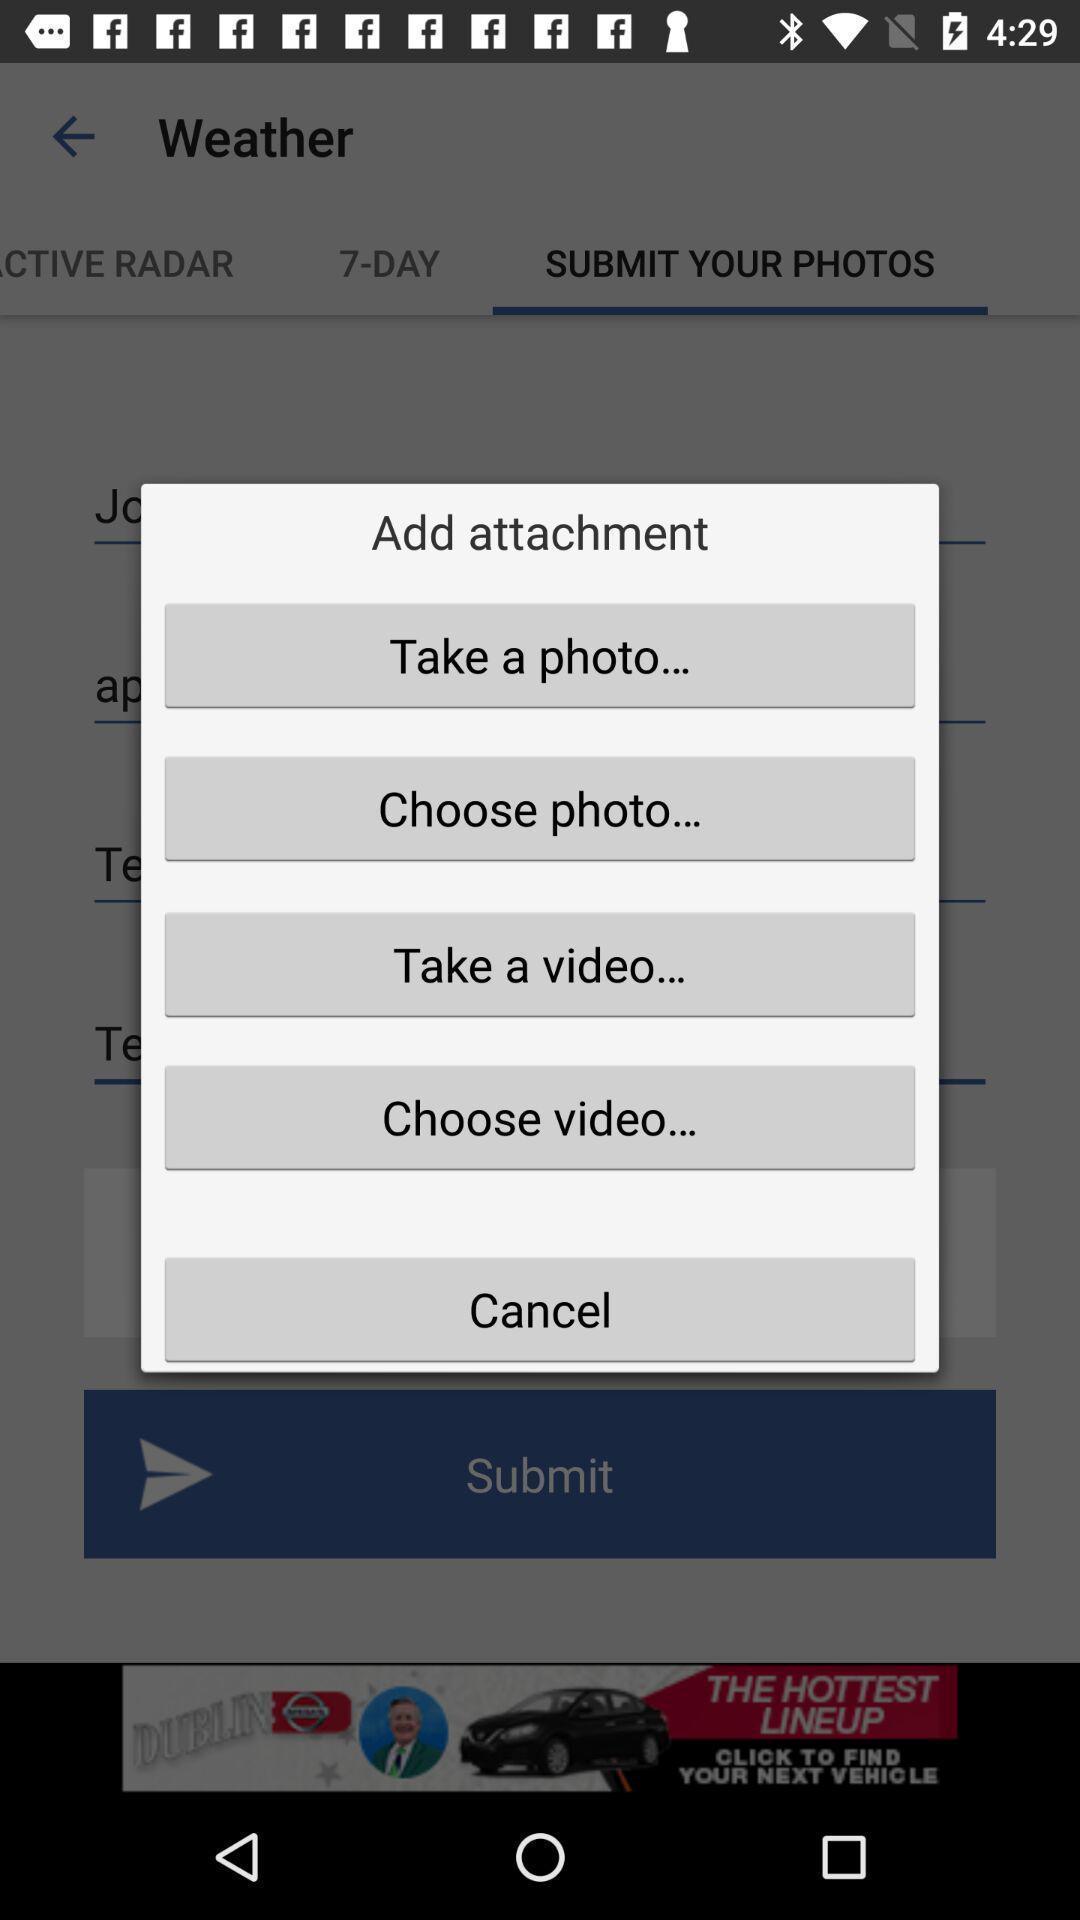What details can you identify in this image? Popup of various types sources to attach the file. 